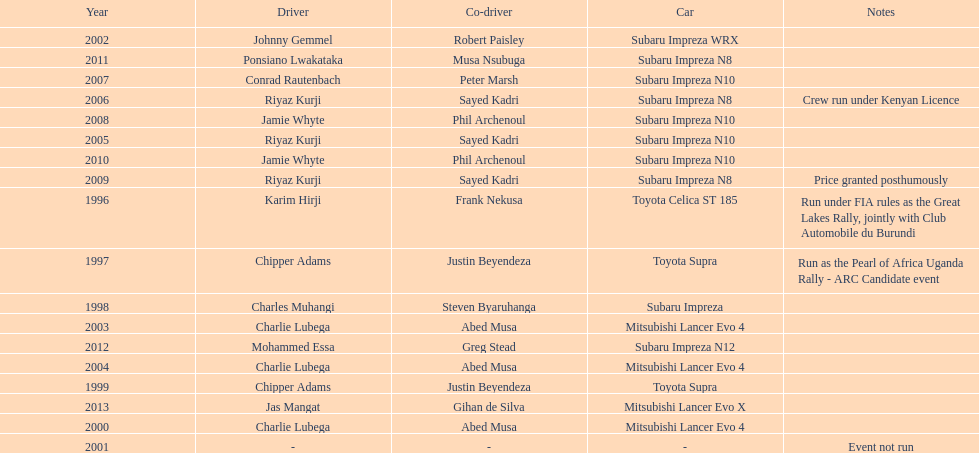Which driver won after ponsiano lwakataka? Mohammed Essa. 